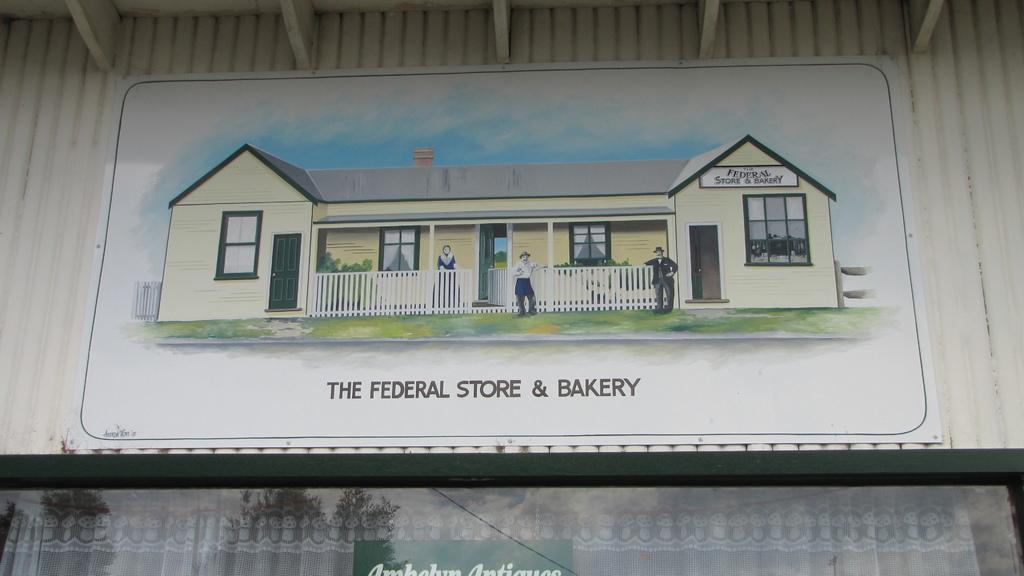What type of structure is shown in the image? The image depicts a shed. What is located in the center of the image? There is a poster in the center of the image. What items are at the bottom of the image? There is cloth and a board at the bottom of the image. What can be seen in the background of the image? The background of the image includes a roof and a wall. How many tomatoes are hanging from the roof in the image? There are no tomatoes present in the image; it only features a shed, a poster, cloth, a board, and a wall. What type of silver material is used to construct the shed in the image? The shed is not made of silver, and there is no mention of any silver material in the image. 